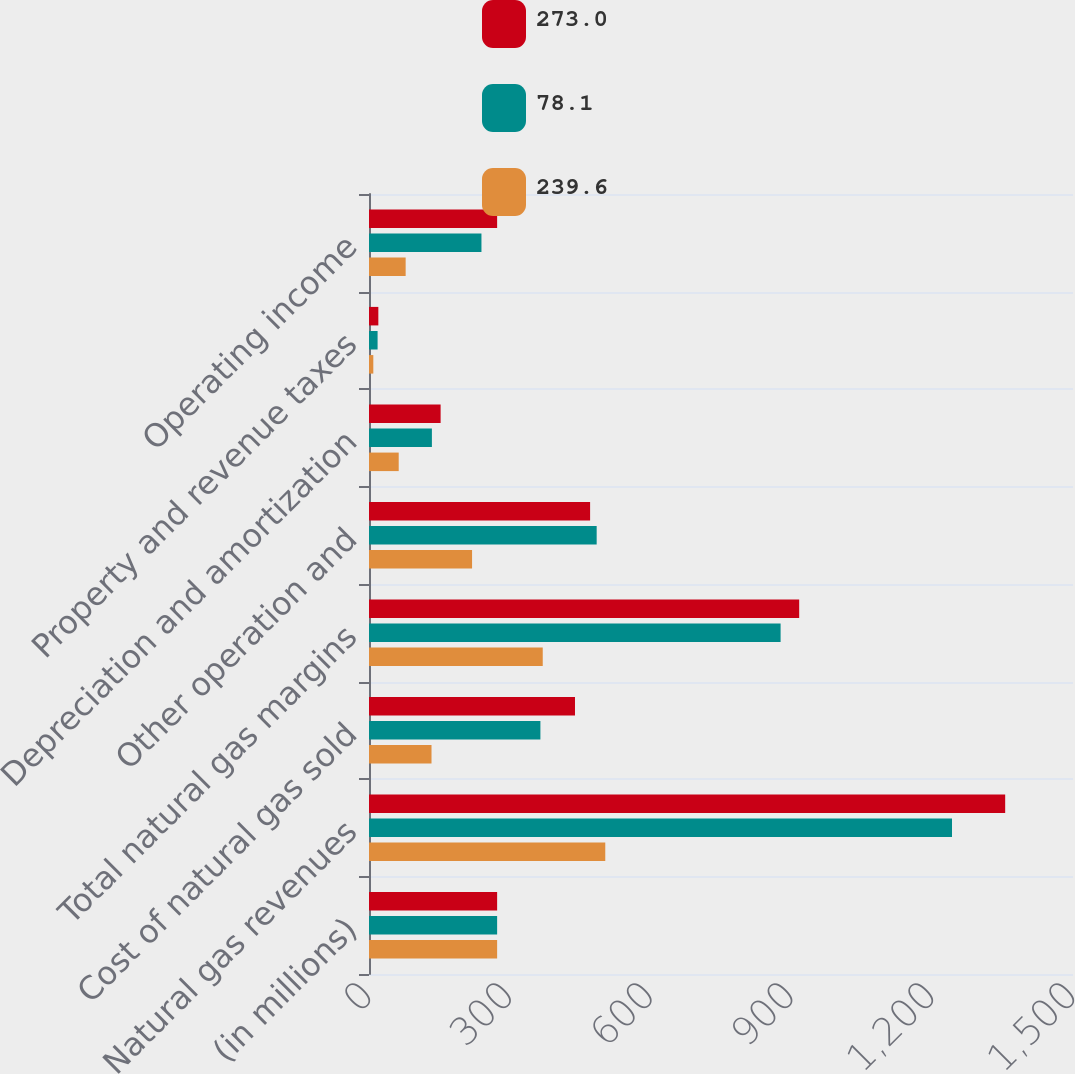<chart> <loc_0><loc_0><loc_500><loc_500><stacked_bar_chart><ecel><fcel>(in millions)<fcel>Natural gas revenues<fcel>Cost of natural gas sold<fcel>Total natural gas margins<fcel>Other operation and<fcel>Depreciation and amortization<fcel>Property and revenue taxes<fcel>Operating income<nl><fcel>273<fcel>273<fcel>1355.5<fcel>438.9<fcel>916.6<fcel>471.1<fcel>152.6<fcel>19.9<fcel>273<nl><fcel>78.1<fcel>273<fcel>1242.2<fcel>365.2<fcel>877<fcel>485.1<fcel>134<fcel>18.3<fcel>239.6<nl><fcel>239.6<fcel>273<fcel>503.4<fcel>133.2<fcel>370.2<fcel>219.6<fcel>63.3<fcel>9.2<fcel>78.1<nl></chart> 